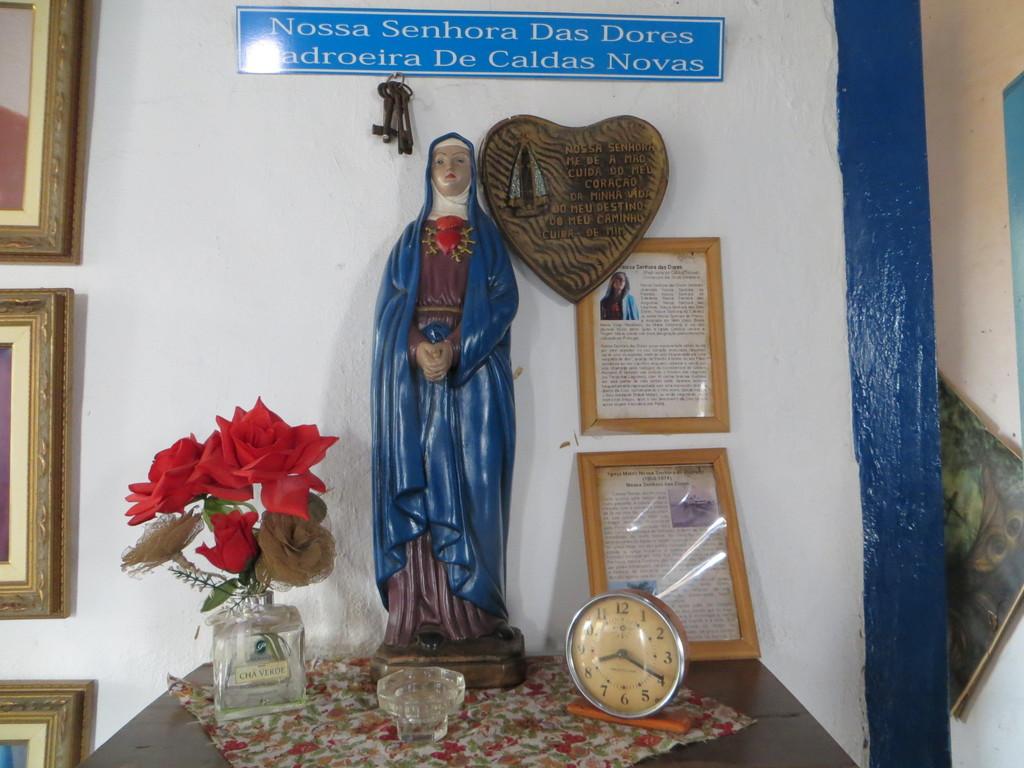What time is shown on the clock?
Provide a short and direct response. 8:20. 